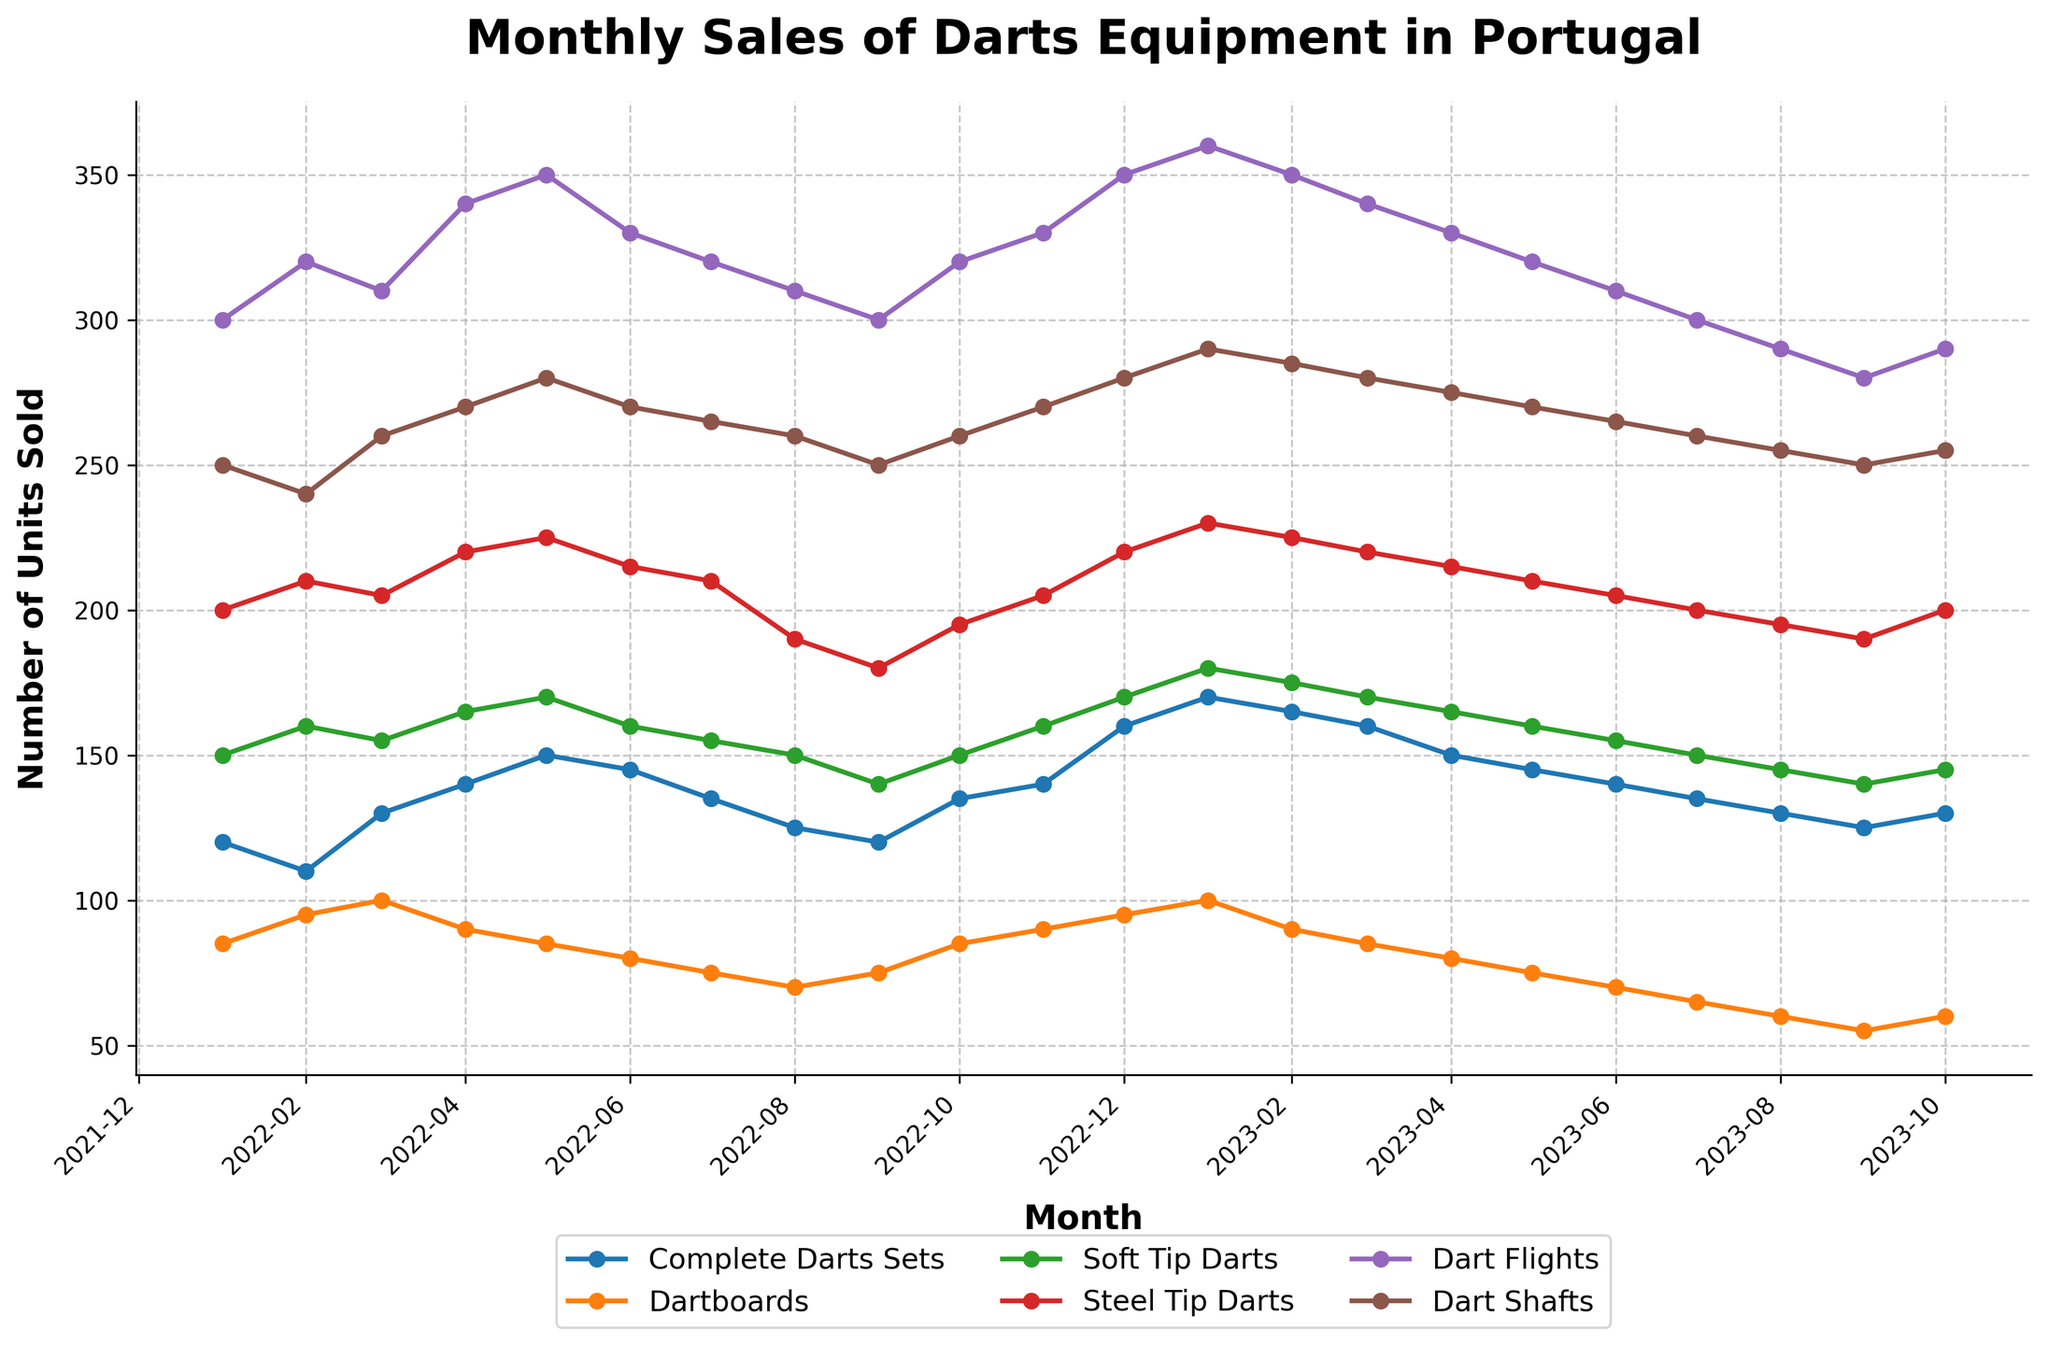What is the title of the plot? The title is usually displayed at the top of the chart and provides an overview of what is being illustrated. In this case, the title specifically mentions the data and location.
Answer: Monthly Sales of Darts Equipment in Portugal How many different types of darts products are displayed in the figure? The number of different types can be determined by counting the distinct lines or products listed in the legend.
Answer: Six Which darts product had the highest sales in January 2023? Observing the y-values for January 2023 across different lines will indicate the highest sales.
Answer: Dart Flights What month had the lowest sales for Dartboards, and how many units were sold? Identify the lowest point on the Dartboards line and check its corresponding month and y-value.
Answer: September 2023, 55 units During which month in 2022 were the sales of Complete Darts Sets and Steel Tip Darts equal? Check the plot for months in 2022 where the y-values of Complete Darts Sets and Steel Tip Darts intersect.
Answer: January 2022 What is the average monthly sales of Soft Tip Darts from January 2022 to October 2023? Calculate the average by summing up the sales of Soft Tip Darts from the dataset and dividing by the number of months considered.
Answer: 158.6 Which product saw the most significant increase in sales from December 2022 to January 2023? Compare the increase in y-values between December 2022 and January 2023 for each product and identify the largest one.
Answer: Complete Darts Sets Compare the trend in sales of Soft Tip Darts and Steel Tip Darts throughout the period. Which one generally shows higher sales? Observe the overall positions of the lines representing Soft Tip Darts and Steel Tip Darts throughout the timeframe.
Answer: Steel Tip Darts In which month did Dart Shafts experience the same sales as Dart Flights in 2023, and what was the value? Look for the month in the plot for 2023 where the lines for Dart Shafts and Dart Flights intersect.
Answer: October 2023, 255 units 